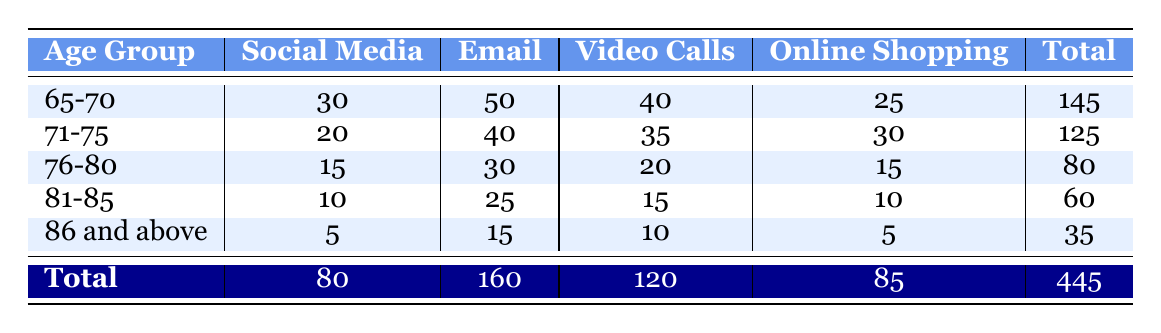What is the total number of seniors using email in the age group 76-80? In the table, looking under the "Email" column for the age group "76-80," the value is 30. This indicates that thirty seniors aged 76 to 80 use email.
Answer: 30 Which age group has the highest usage of social media? By examining the "Social Media" column, the age group "65-70" has the highest value of 30. No other age groups exceed this number.
Answer: 65-70 What is the total number of seniors using online shopping across all age groups? To find the total, I will sum the values in the "Online Shopping" column: 25 (65-70) + 30 (71-75) + 15 (76-80) + 10 (81-85) + 5 (86 and above) = 85. Therefore, the total is 85.
Answer: 85 Is it true that more seniors aged 71-75 use video calls than those aged 81-85? In the "Video Calls" column, the value for age group 71-75 is 35 while for 81-85 it is 15. Since 35 is greater than 15, the statement is true.
Answer: Yes What is the average number of social media users among the age groups? To calculate the average, I sum the social media users: 30 (65-70) + 20 (71-75) + 15 (76-80) + 10 (81-85) + 5 (86 and above) = 80. There are 5 age groups, so the average is 80/5 = 16.
Answer: 16 Which activity has the lowest total usage across all age groups? The totals for each activity are: Social Media = 80, Email = 160, Video Calls = 120, Online Shopping = 85. The lowest total is for Social Media, with a value of 80.
Answer: Social Media How many more seniors aged 65-70 use email compared to those aged 86 and above? For email, the number of users aged 65-70 is 50, and for those aged 86 and above, it is 15. The difference is 50 - 15 = 35. Thus, there are 35 more seniors in the 65-70 age group using email.
Answer: 35 What percentage of total seniors use online shopping in the 76-80 age group? First, I find the total number of seniors across all groups, which is 445. The number of seniors in the 76-80 age group using online shopping is 15. The percentage is (15/445) * 100 = approximately 3.37%.
Answer: 3.37% 